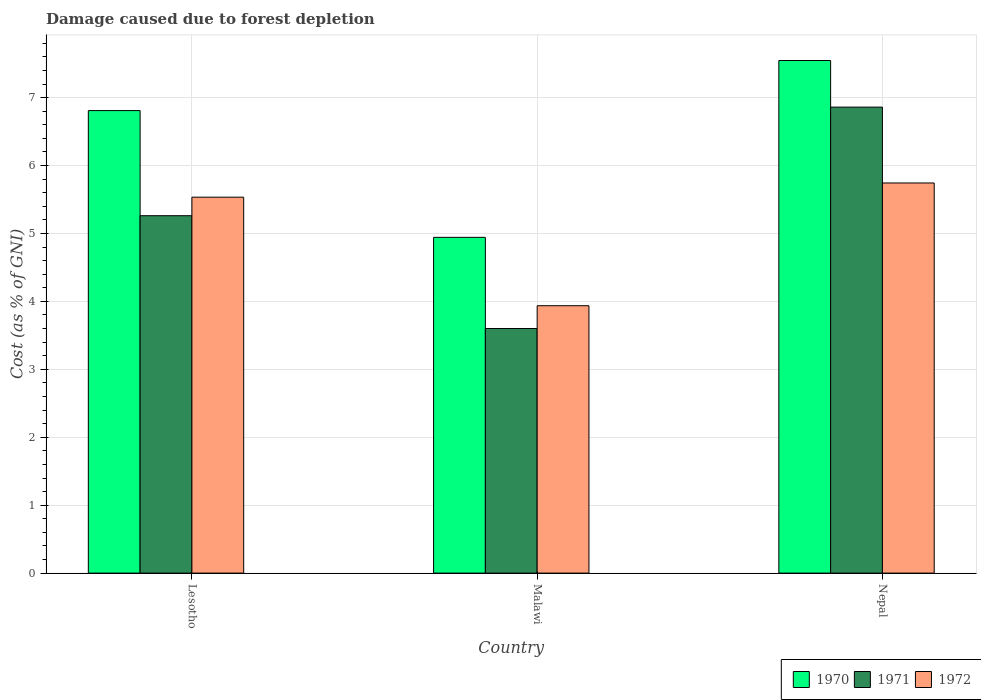How many groups of bars are there?
Your response must be concise. 3. What is the label of the 3rd group of bars from the left?
Ensure brevity in your answer.  Nepal. What is the cost of damage caused due to forest depletion in 1971 in Lesotho?
Provide a succinct answer. 5.26. Across all countries, what is the maximum cost of damage caused due to forest depletion in 1970?
Your response must be concise. 7.55. Across all countries, what is the minimum cost of damage caused due to forest depletion in 1970?
Offer a terse response. 4.94. In which country was the cost of damage caused due to forest depletion in 1971 maximum?
Make the answer very short. Nepal. In which country was the cost of damage caused due to forest depletion in 1971 minimum?
Offer a terse response. Malawi. What is the total cost of damage caused due to forest depletion in 1971 in the graph?
Offer a very short reply. 15.72. What is the difference between the cost of damage caused due to forest depletion in 1970 in Lesotho and that in Malawi?
Keep it short and to the point. 1.87. What is the difference between the cost of damage caused due to forest depletion in 1970 in Nepal and the cost of damage caused due to forest depletion in 1971 in Malawi?
Your answer should be compact. 3.95. What is the average cost of damage caused due to forest depletion in 1971 per country?
Your response must be concise. 5.24. What is the difference between the cost of damage caused due to forest depletion of/in 1971 and cost of damage caused due to forest depletion of/in 1972 in Malawi?
Provide a succinct answer. -0.34. In how many countries, is the cost of damage caused due to forest depletion in 1972 greater than 4 %?
Your answer should be compact. 2. What is the ratio of the cost of damage caused due to forest depletion in 1971 in Lesotho to that in Nepal?
Make the answer very short. 0.77. Is the cost of damage caused due to forest depletion in 1971 in Lesotho less than that in Nepal?
Keep it short and to the point. Yes. Is the difference between the cost of damage caused due to forest depletion in 1971 in Malawi and Nepal greater than the difference between the cost of damage caused due to forest depletion in 1972 in Malawi and Nepal?
Your response must be concise. No. What is the difference between the highest and the second highest cost of damage caused due to forest depletion in 1972?
Your response must be concise. 1.6. What is the difference between the highest and the lowest cost of damage caused due to forest depletion in 1970?
Ensure brevity in your answer.  2.6. In how many countries, is the cost of damage caused due to forest depletion in 1970 greater than the average cost of damage caused due to forest depletion in 1970 taken over all countries?
Offer a terse response. 2. Is the sum of the cost of damage caused due to forest depletion in 1970 in Lesotho and Nepal greater than the maximum cost of damage caused due to forest depletion in 1971 across all countries?
Your answer should be very brief. Yes. Is it the case that in every country, the sum of the cost of damage caused due to forest depletion in 1972 and cost of damage caused due to forest depletion in 1970 is greater than the cost of damage caused due to forest depletion in 1971?
Give a very brief answer. Yes. What is the difference between two consecutive major ticks on the Y-axis?
Your response must be concise. 1. Are the values on the major ticks of Y-axis written in scientific E-notation?
Your answer should be very brief. No. Does the graph contain any zero values?
Provide a short and direct response. No. Where does the legend appear in the graph?
Offer a terse response. Bottom right. What is the title of the graph?
Ensure brevity in your answer.  Damage caused due to forest depletion. Does "1969" appear as one of the legend labels in the graph?
Offer a very short reply. No. What is the label or title of the Y-axis?
Keep it short and to the point. Cost (as % of GNI). What is the Cost (as % of GNI) in 1970 in Lesotho?
Your response must be concise. 6.81. What is the Cost (as % of GNI) of 1971 in Lesotho?
Make the answer very short. 5.26. What is the Cost (as % of GNI) of 1972 in Lesotho?
Give a very brief answer. 5.53. What is the Cost (as % of GNI) in 1970 in Malawi?
Make the answer very short. 4.94. What is the Cost (as % of GNI) of 1971 in Malawi?
Ensure brevity in your answer.  3.6. What is the Cost (as % of GNI) of 1972 in Malawi?
Offer a terse response. 3.94. What is the Cost (as % of GNI) of 1970 in Nepal?
Give a very brief answer. 7.55. What is the Cost (as % of GNI) of 1971 in Nepal?
Ensure brevity in your answer.  6.86. What is the Cost (as % of GNI) of 1972 in Nepal?
Offer a very short reply. 5.74. Across all countries, what is the maximum Cost (as % of GNI) in 1970?
Your response must be concise. 7.55. Across all countries, what is the maximum Cost (as % of GNI) in 1971?
Provide a short and direct response. 6.86. Across all countries, what is the maximum Cost (as % of GNI) in 1972?
Make the answer very short. 5.74. Across all countries, what is the minimum Cost (as % of GNI) of 1970?
Your answer should be very brief. 4.94. Across all countries, what is the minimum Cost (as % of GNI) of 1971?
Your answer should be very brief. 3.6. Across all countries, what is the minimum Cost (as % of GNI) in 1972?
Offer a terse response. 3.94. What is the total Cost (as % of GNI) of 1970 in the graph?
Keep it short and to the point. 19.3. What is the total Cost (as % of GNI) in 1971 in the graph?
Offer a very short reply. 15.72. What is the total Cost (as % of GNI) of 1972 in the graph?
Your answer should be compact. 15.21. What is the difference between the Cost (as % of GNI) of 1970 in Lesotho and that in Malawi?
Keep it short and to the point. 1.87. What is the difference between the Cost (as % of GNI) of 1971 in Lesotho and that in Malawi?
Give a very brief answer. 1.66. What is the difference between the Cost (as % of GNI) of 1972 in Lesotho and that in Malawi?
Your answer should be compact. 1.6. What is the difference between the Cost (as % of GNI) in 1970 in Lesotho and that in Nepal?
Offer a terse response. -0.74. What is the difference between the Cost (as % of GNI) in 1971 in Lesotho and that in Nepal?
Provide a succinct answer. -1.6. What is the difference between the Cost (as % of GNI) in 1972 in Lesotho and that in Nepal?
Give a very brief answer. -0.21. What is the difference between the Cost (as % of GNI) in 1970 in Malawi and that in Nepal?
Your answer should be compact. -2.6. What is the difference between the Cost (as % of GNI) of 1971 in Malawi and that in Nepal?
Your answer should be compact. -3.26. What is the difference between the Cost (as % of GNI) in 1972 in Malawi and that in Nepal?
Make the answer very short. -1.81. What is the difference between the Cost (as % of GNI) of 1970 in Lesotho and the Cost (as % of GNI) of 1971 in Malawi?
Keep it short and to the point. 3.21. What is the difference between the Cost (as % of GNI) in 1970 in Lesotho and the Cost (as % of GNI) in 1972 in Malawi?
Your response must be concise. 2.87. What is the difference between the Cost (as % of GNI) in 1971 in Lesotho and the Cost (as % of GNI) in 1972 in Malawi?
Offer a terse response. 1.33. What is the difference between the Cost (as % of GNI) in 1970 in Lesotho and the Cost (as % of GNI) in 1971 in Nepal?
Your answer should be very brief. -0.05. What is the difference between the Cost (as % of GNI) in 1970 in Lesotho and the Cost (as % of GNI) in 1972 in Nepal?
Keep it short and to the point. 1.07. What is the difference between the Cost (as % of GNI) of 1971 in Lesotho and the Cost (as % of GNI) of 1972 in Nepal?
Make the answer very short. -0.48. What is the difference between the Cost (as % of GNI) of 1970 in Malawi and the Cost (as % of GNI) of 1971 in Nepal?
Give a very brief answer. -1.92. What is the difference between the Cost (as % of GNI) of 1970 in Malawi and the Cost (as % of GNI) of 1972 in Nepal?
Make the answer very short. -0.8. What is the difference between the Cost (as % of GNI) of 1971 in Malawi and the Cost (as % of GNI) of 1972 in Nepal?
Make the answer very short. -2.14. What is the average Cost (as % of GNI) of 1970 per country?
Your answer should be compact. 6.43. What is the average Cost (as % of GNI) in 1971 per country?
Your response must be concise. 5.24. What is the average Cost (as % of GNI) in 1972 per country?
Make the answer very short. 5.07. What is the difference between the Cost (as % of GNI) of 1970 and Cost (as % of GNI) of 1971 in Lesotho?
Give a very brief answer. 1.55. What is the difference between the Cost (as % of GNI) of 1970 and Cost (as % of GNI) of 1972 in Lesotho?
Make the answer very short. 1.27. What is the difference between the Cost (as % of GNI) of 1971 and Cost (as % of GNI) of 1972 in Lesotho?
Provide a short and direct response. -0.27. What is the difference between the Cost (as % of GNI) in 1970 and Cost (as % of GNI) in 1971 in Malawi?
Provide a succinct answer. 1.34. What is the difference between the Cost (as % of GNI) in 1970 and Cost (as % of GNI) in 1972 in Malawi?
Keep it short and to the point. 1.01. What is the difference between the Cost (as % of GNI) of 1971 and Cost (as % of GNI) of 1972 in Malawi?
Provide a short and direct response. -0.34. What is the difference between the Cost (as % of GNI) in 1970 and Cost (as % of GNI) in 1971 in Nepal?
Your answer should be very brief. 0.69. What is the difference between the Cost (as % of GNI) in 1970 and Cost (as % of GNI) in 1972 in Nepal?
Your response must be concise. 1.8. What is the difference between the Cost (as % of GNI) in 1971 and Cost (as % of GNI) in 1972 in Nepal?
Provide a short and direct response. 1.12. What is the ratio of the Cost (as % of GNI) in 1970 in Lesotho to that in Malawi?
Keep it short and to the point. 1.38. What is the ratio of the Cost (as % of GNI) of 1971 in Lesotho to that in Malawi?
Your answer should be very brief. 1.46. What is the ratio of the Cost (as % of GNI) in 1972 in Lesotho to that in Malawi?
Ensure brevity in your answer.  1.41. What is the ratio of the Cost (as % of GNI) in 1970 in Lesotho to that in Nepal?
Give a very brief answer. 0.9. What is the ratio of the Cost (as % of GNI) in 1971 in Lesotho to that in Nepal?
Your answer should be compact. 0.77. What is the ratio of the Cost (as % of GNI) in 1972 in Lesotho to that in Nepal?
Your answer should be compact. 0.96. What is the ratio of the Cost (as % of GNI) in 1970 in Malawi to that in Nepal?
Offer a terse response. 0.66. What is the ratio of the Cost (as % of GNI) in 1971 in Malawi to that in Nepal?
Give a very brief answer. 0.52. What is the ratio of the Cost (as % of GNI) of 1972 in Malawi to that in Nepal?
Provide a succinct answer. 0.69. What is the difference between the highest and the second highest Cost (as % of GNI) in 1970?
Your answer should be very brief. 0.74. What is the difference between the highest and the second highest Cost (as % of GNI) in 1971?
Offer a terse response. 1.6. What is the difference between the highest and the second highest Cost (as % of GNI) of 1972?
Offer a terse response. 0.21. What is the difference between the highest and the lowest Cost (as % of GNI) in 1970?
Your answer should be compact. 2.6. What is the difference between the highest and the lowest Cost (as % of GNI) in 1971?
Your response must be concise. 3.26. What is the difference between the highest and the lowest Cost (as % of GNI) in 1972?
Provide a short and direct response. 1.81. 